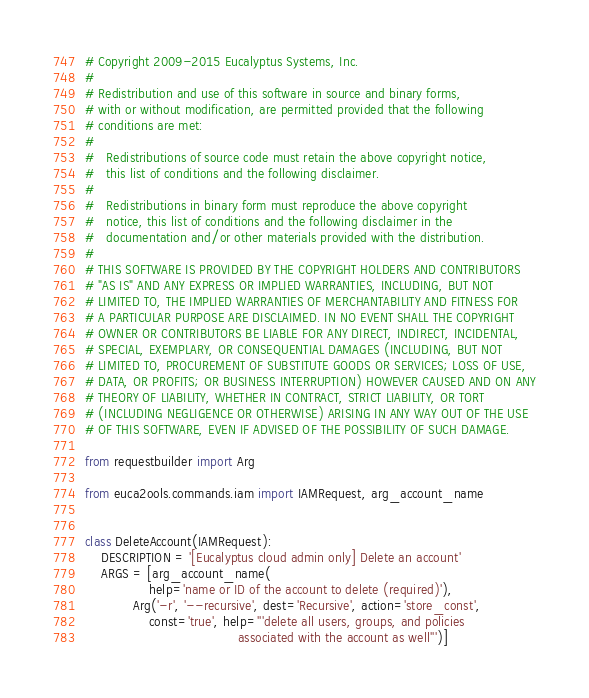<code> <loc_0><loc_0><loc_500><loc_500><_Python_># Copyright 2009-2015 Eucalyptus Systems, Inc.
#
# Redistribution and use of this software in source and binary forms,
# with or without modification, are permitted provided that the following
# conditions are met:
#
#   Redistributions of source code must retain the above copyright notice,
#   this list of conditions and the following disclaimer.
#
#   Redistributions in binary form must reproduce the above copyright
#   notice, this list of conditions and the following disclaimer in the
#   documentation and/or other materials provided with the distribution.
#
# THIS SOFTWARE IS PROVIDED BY THE COPYRIGHT HOLDERS AND CONTRIBUTORS
# "AS IS" AND ANY EXPRESS OR IMPLIED WARRANTIES, INCLUDING, BUT NOT
# LIMITED TO, THE IMPLIED WARRANTIES OF MERCHANTABILITY AND FITNESS FOR
# A PARTICULAR PURPOSE ARE DISCLAIMED. IN NO EVENT SHALL THE COPYRIGHT
# OWNER OR CONTRIBUTORS BE LIABLE FOR ANY DIRECT, INDIRECT, INCIDENTAL,
# SPECIAL, EXEMPLARY, OR CONSEQUENTIAL DAMAGES (INCLUDING, BUT NOT
# LIMITED TO, PROCUREMENT OF SUBSTITUTE GOODS OR SERVICES; LOSS OF USE,
# DATA, OR PROFITS; OR BUSINESS INTERRUPTION) HOWEVER CAUSED AND ON ANY
# THEORY OF LIABILITY, WHETHER IN CONTRACT, STRICT LIABILITY, OR TORT
# (INCLUDING NEGLIGENCE OR OTHERWISE) ARISING IN ANY WAY OUT OF THE USE
# OF THIS SOFTWARE, EVEN IF ADVISED OF THE POSSIBILITY OF SUCH DAMAGE.

from requestbuilder import Arg

from euca2ools.commands.iam import IAMRequest, arg_account_name


class DeleteAccount(IAMRequest):
    DESCRIPTION = '[Eucalyptus cloud admin only] Delete an account'
    ARGS = [arg_account_name(
                help='name or ID of the account to delete (required)'),
            Arg('-r', '--recursive', dest='Recursive', action='store_const',
                const='true', help='''delete all users, groups, and policies
                                      associated with the account as well''')]
</code> 